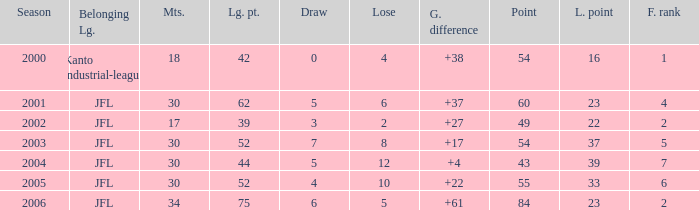I want the total number of matches for draw less than 7 and lost point of 16 with lose more than 4 0.0. 